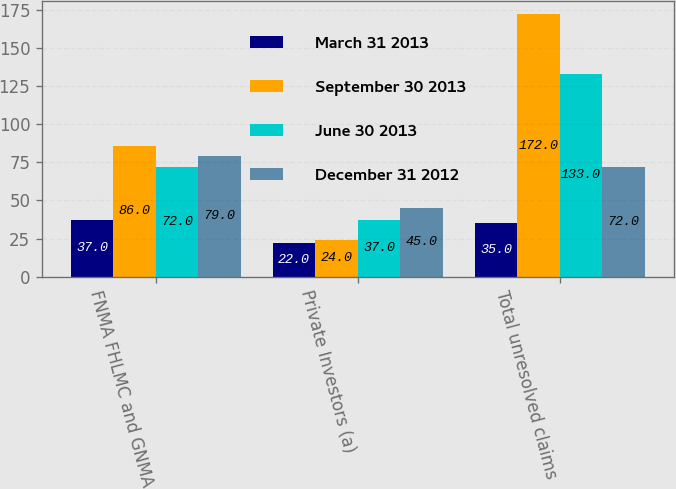<chart> <loc_0><loc_0><loc_500><loc_500><stacked_bar_chart><ecel><fcel>FNMA FHLMC and GNMA<fcel>Private Investors (a)<fcel>Total unresolved claims<nl><fcel>March 31 2013<fcel>37<fcel>22<fcel>35<nl><fcel>September 30 2013<fcel>86<fcel>24<fcel>172<nl><fcel>June 30 2013<fcel>72<fcel>37<fcel>133<nl><fcel>December 31 2012<fcel>79<fcel>45<fcel>72<nl></chart> 